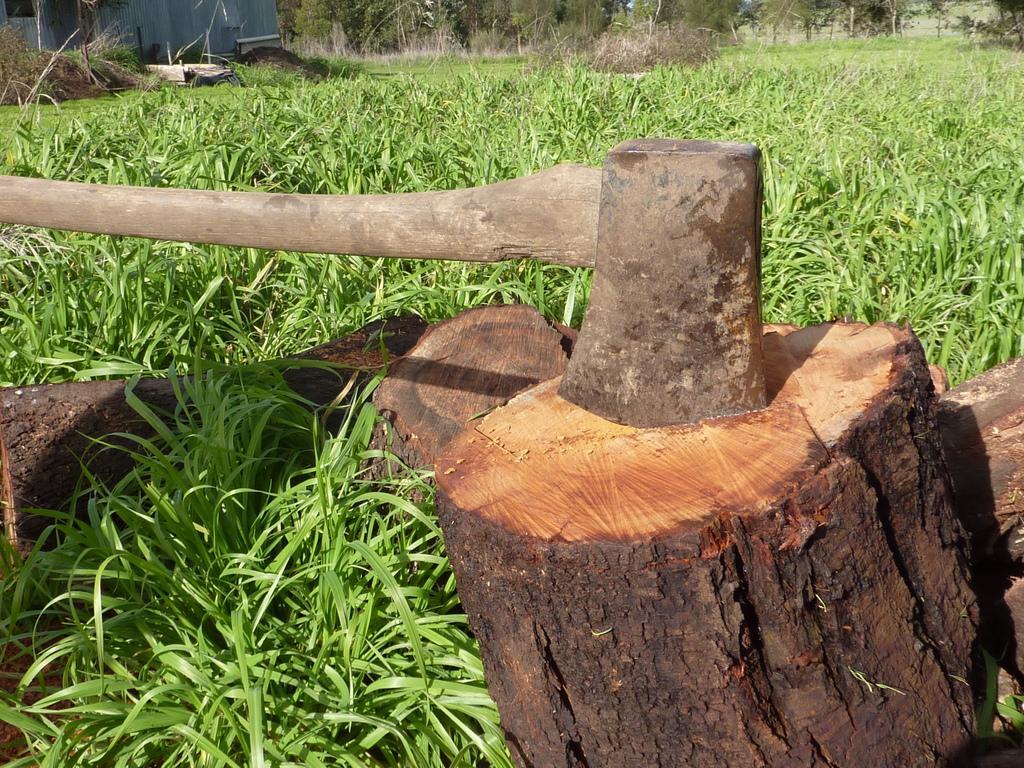Can you describe this image briefly? In this picture we can see a tree bark and an axe in the front, at the bottom there is grass, in the background we can see some trees. 